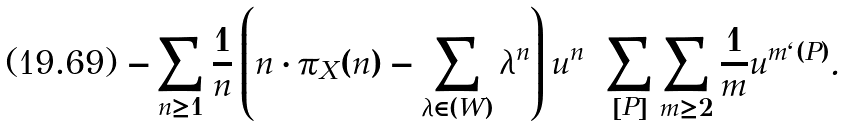Convert formula to latex. <formula><loc_0><loc_0><loc_500><loc_500>- \sum _ { n \geq 1 } \frac { 1 } { n } \left ( n \cdot \pi _ { X } ( n ) - \sum _ { \lambda \in ( W ) } \lambda ^ { n } \right ) u ^ { n } = \sum _ { [ P ] } \sum _ { m \geq 2 } \frac { 1 } { m } u ^ { m \ell ( P ) } .</formula> 